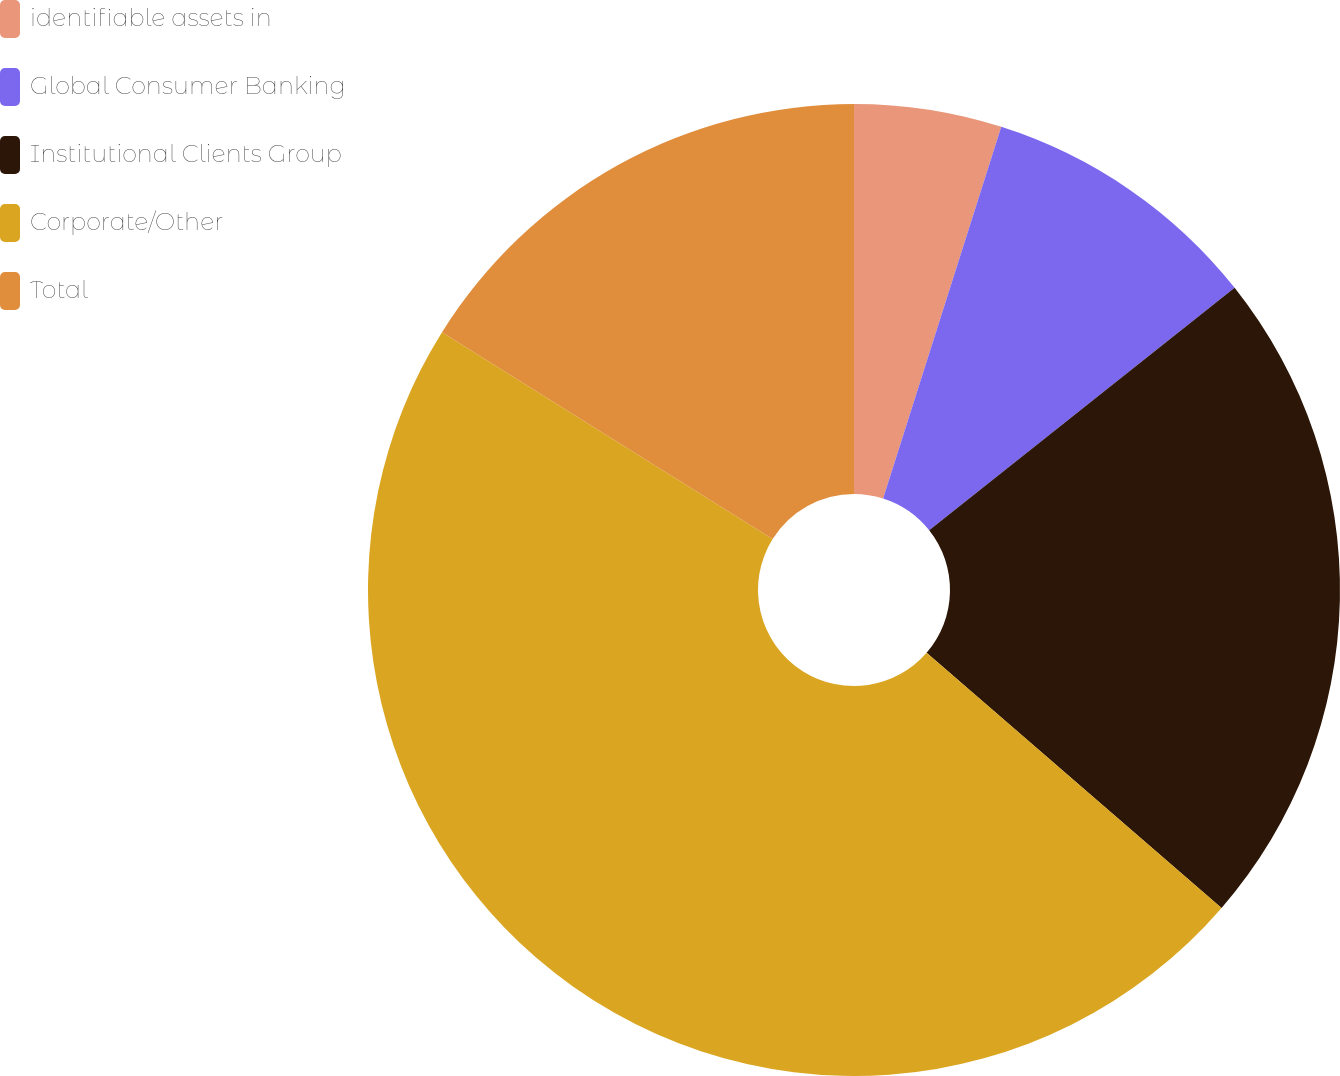Convert chart to OTSL. <chart><loc_0><loc_0><loc_500><loc_500><pie_chart><fcel>identifiable assets in<fcel>Global Consumer Banking<fcel>Institutional Clients Group<fcel>Corporate/Other<fcel>Total<nl><fcel>4.9%<fcel>9.42%<fcel>22.03%<fcel>47.55%<fcel>16.1%<nl></chart> 